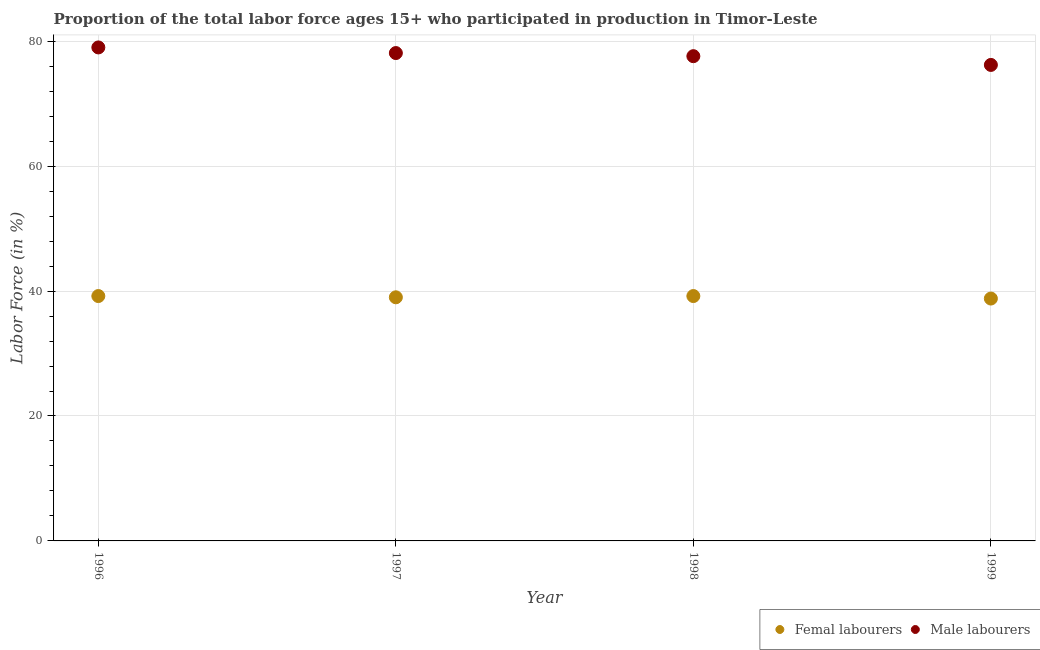What is the percentage of female labor force in 1996?
Your answer should be compact. 39.2. Across all years, what is the maximum percentage of female labor force?
Your answer should be very brief. 39.2. Across all years, what is the minimum percentage of male labour force?
Provide a short and direct response. 76.2. In which year was the percentage of female labor force maximum?
Ensure brevity in your answer.  1996. In which year was the percentage of male labour force minimum?
Ensure brevity in your answer.  1999. What is the total percentage of female labor force in the graph?
Your response must be concise. 156.2. What is the difference between the percentage of male labour force in 1998 and that in 1999?
Offer a very short reply. 1.4. What is the difference between the percentage of female labor force in 1997 and the percentage of male labour force in 1999?
Make the answer very short. -37.2. What is the average percentage of male labour force per year?
Your response must be concise. 77.72. In the year 1997, what is the difference between the percentage of female labor force and percentage of male labour force?
Give a very brief answer. -39.1. What is the ratio of the percentage of male labour force in 1998 to that in 1999?
Offer a terse response. 1.02. Is the percentage of male labour force in 1996 less than that in 1998?
Ensure brevity in your answer.  No. Is the difference between the percentage of female labor force in 1997 and 1998 greater than the difference between the percentage of male labour force in 1997 and 1998?
Your response must be concise. No. What is the difference between the highest and the lowest percentage of male labour force?
Your answer should be compact. 2.8. In how many years, is the percentage of female labor force greater than the average percentage of female labor force taken over all years?
Make the answer very short. 2. Is the percentage of female labor force strictly less than the percentage of male labour force over the years?
Your answer should be compact. Yes. How many dotlines are there?
Your answer should be very brief. 2. What is the difference between two consecutive major ticks on the Y-axis?
Make the answer very short. 20. Does the graph contain any zero values?
Offer a terse response. No. Does the graph contain grids?
Offer a very short reply. Yes. What is the title of the graph?
Offer a terse response. Proportion of the total labor force ages 15+ who participated in production in Timor-Leste. Does "Mineral" appear as one of the legend labels in the graph?
Provide a short and direct response. No. What is the Labor Force (in %) of Femal labourers in 1996?
Provide a short and direct response. 39.2. What is the Labor Force (in %) of Male labourers in 1996?
Keep it short and to the point. 79. What is the Labor Force (in %) of Male labourers in 1997?
Offer a very short reply. 78.1. What is the Labor Force (in %) of Femal labourers in 1998?
Offer a terse response. 39.2. What is the Labor Force (in %) in Male labourers in 1998?
Your response must be concise. 77.6. What is the Labor Force (in %) of Femal labourers in 1999?
Your answer should be compact. 38.8. What is the Labor Force (in %) in Male labourers in 1999?
Provide a short and direct response. 76.2. Across all years, what is the maximum Labor Force (in %) in Femal labourers?
Ensure brevity in your answer.  39.2. Across all years, what is the maximum Labor Force (in %) of Male labourers?
Your response must be concise. 79. Across all years, what is the minimum Labor Force (in %) in Femal labourers?
Provide a succinct answer. 38.8. Across all years, what is the minimum Labor Force (in %) of Male labourers?
Your answer should be compact. 76.2. What is the total Labor Force (in %) in Femal labourers in the graph?
Keep it short and to the point. 156.2. What is the total Labor Force (in %) in Male labourers in the graph?
Offer a very short reply. 310.9. What is the difference between the Labor Force (in %) in Male labourers in 1996 and that in 1997?
Give a very brief answer. 0.9. What is the difference between the Labor Force (in %) of Male labourers in 1996 and that in 1998?
Your response must be concise. 1.4. What is the difference between the Labor Force (in %) of Male labourers in 1996 and that in 1999?
Give a very brief answer. 2.8. What is the difference between the Labor Force (in %) in Femal labourers in 1997 and that in 1999?
Keep it short and to the point. 0.2. What is the difference between the Labor Force (in %) of Male labourers in 1997 and that in 1999?
Offer a terse response. 1.9. What is the difference between the Labor Force (in %) in Femal labourers in 1998 and that in 1999?
Ensure brevity in your answer.  0.4. What is the difference between the Labor Force (in %) of Male labourers in 1998 and that in 1999?
Your answer should be very brief. 1.4. What is the difference between the Labor Force (in %) of Femal labourers in 1996 and the Labor Force (in %) of Male labourers in 1997?
Provide a short and direct response. -38.9. What is the difference between the Labor Force (in %) of Femal labourers in 1996 and the Labor Force (in %) of Male labourers in 1998?
Your response must be concise. -38.4. What is the difference between the Labor Force (in %) of Femal labourers in 1996 and the Labor Force (in %) of Male labourers in 1999?
Offer a terse response. -37. What is the difference between the Labor Force (in %) in Femal labourers in 1997 and the Labor Force (in %) in Male labourers in 1998?
Make the answer very short. -38.6. What is the difference between the Labor Force (in %) in Femal labourers in 1997 and the Labor Force (in %) in Male labourers in 1999?
Your answer should be very brief. -37.2. What is the difference between the Labor Force (in %) in Femal labourers in 1998 and the Labor Force (in %) in Male labourers in 1999?
Keep it short and to the point. -37. What is the average Labor Force (in %) in Femal labourers per year?
Offer a very short reply. 39.05. What is the average Labor Force (in %) of Male labourers per year?
Keep it short and to the point. 77.72. In the year 1996, what is the difference between the Labor Force (in %) of Femal labourers and Labor Force (in %) of Male labourers?
Your answer should be very brief. -39.8. In the year 1997, what is the difference between the Labor Force (in %) in Femal labourers and Labor Force (in %) in Male labourers?
Your answer should be compact. -39.1. In the year 1998, what is the difference between the Labor Force (in %) of Femal labourers and Labor Force (in %) of Male labourers?
Offer a terse response. -38.4. In the year 1999, what is the difference between the Labor Force (in %) of Femal labourers and Labor Force (in %) of Male labourers?
Your answer should be compact. -37.4. What is the ratio of the Labor Force (in %) in Femal labourers in 1996 to that in 1997?
Offer a very short reply. 1.01. What is the ratio of the Labor Force (in %) of Male labourers in 1996 to that in 1997?
Your answer should be compact. 1.01. What is the ratio of the Labor Force (in %) in Femal labourers in 1996 to that in 1998?
Offer a very short reply. 1. What is the ratio of the Labor Force (in %) of Male labourers in 1996 to that in 1998?
Provide a short and direct response. 1.02. What is the ratio of the Labor Force (in %) of Femal labourers in 1996 to that in 1999?
Provide a succinct answer. 1.01. What is the ratio of the Labor Force (in %) in Male labourers in 1996 to that in 1999?
Your response must be concise. 1.04. What is the ratio of the Labor Force (in %) of Male labourers in 1997 to that in 1998?
Provide a short and direct response. 1.01. What is the ratio of the Labor Force (in %) of Male labourers in 1997 to that in 1999?
Offer a terse response. 1.02. What is the ratio of the Labor Force (in %) of Femal labourers in 1998 to that in 1999?
Provide a succinct answer. 1.01. What is the ratio of the Labor Force (in %) in Male labourers in 1998 to that in 1999?
Make the answer very short. 1.02. What is the difference between the highest and the second highest Labor Force (in %) of Femal labourers?
Offer a very short reply. 0. What is the difference between the highest and the second highest Labor Force (in %) of Male labourers?
Ensure brevity in your answer.  0.9. What is the difference between the highest and the lowest Labor Force (in %) of Male labourers?
Provide a short and direct response. 2.8. 